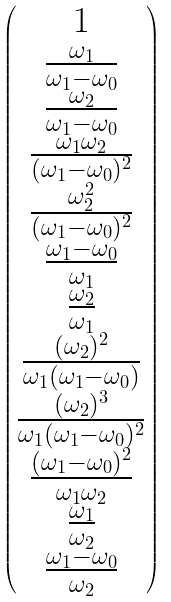<formula> <loc_0><loc_0><loc_500><loc_500>\begin{pmatrix} 1 \\ \frac { \omega _ { 1 } } { \omega _ { 1 } - \omega _ { 0 } } \\ \frac { \omega _ { 2 } } { \omega _ { 1 } - \omega _ { 0 } } \\ \frac { \omega _ { 1 } \omega _ { 2 } } { ( \omega _ { 1 } - \omega _ { 0 } ) ^ { 2 } } \\ \frac { \omega _ { 2 } ^ { 2 } } { ( \omega _ { 1 } - \omega _ { 0 } ) ^ { 2 } } \\ \frac { \omega _ { 1 } - \omega _ { 0 } } { \omega _ { 1 } } \\ \frac { \omega _ { 2 } } { \omega _ { 1 } } \\ \frac { ( \omega _ { 2 } ) ^ { 2 } } { \omega _ { 1 } ( \omega _ { 1 } - \omega _ { 0 } ) } \\ \frac { ( \omega _ { 2 } ) ^ { 3 } } { \omega _ { 1 } ( \omega _ { 1 } - \omega _ { 0 } ) ^ { 2 } } \\ \frac { ( \omega _ { 1 } - \omega _ { 0 } ) ^ { 2 } } { \omega _ { 1 } \omega _ { 2 } } \\ \frac { \omega _ { 1 } } { \omega _ { 2 } } \\ \frac { \omega _ { 1 } - \omega _ { 0 } } { \omega _ { 2 } } \\ \end{pmatrix}</formula> 